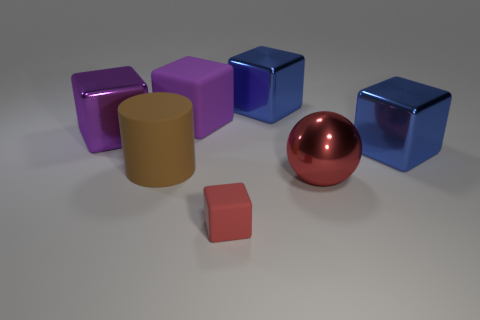There is a rubber cube that is behind the big brown thing; what size is it?
Make the answer very short. Large. There is a large thing that is both to the right of the small red rubber cube and left of the large red sphere; what is its shape?
Ensure brevity in your answer.  Cube. How many other objects are the same shape as the big red shiny thing?
Provide a short and direct response. 0. What color is the metal ball that is the same size as the brown cylinder?
Ensure brevity in your answer.  Red. What number of things are shiny blocks or small purple matte cylinders?
Keep it short and to the point. 3. There is a large brown matte cylinder; are there any blocks in front of it?
Your answer should be compact. Yes. Is there a big purple sphere that has the same material as the cylinder?
Ensure brevity in your answer.  No. The metallic cube that is the same color as the big matte block is what size?
Offer a terse response. Large. How many blocks are either big purple metal things or red rubber things?
Provide a short and direct response. 2. Is the number of big brown matte objects that are in front of the red metal thing greater than the number of tiny red matte cubes that are on the left side of the small matte object?
Your response must be concise. No. 